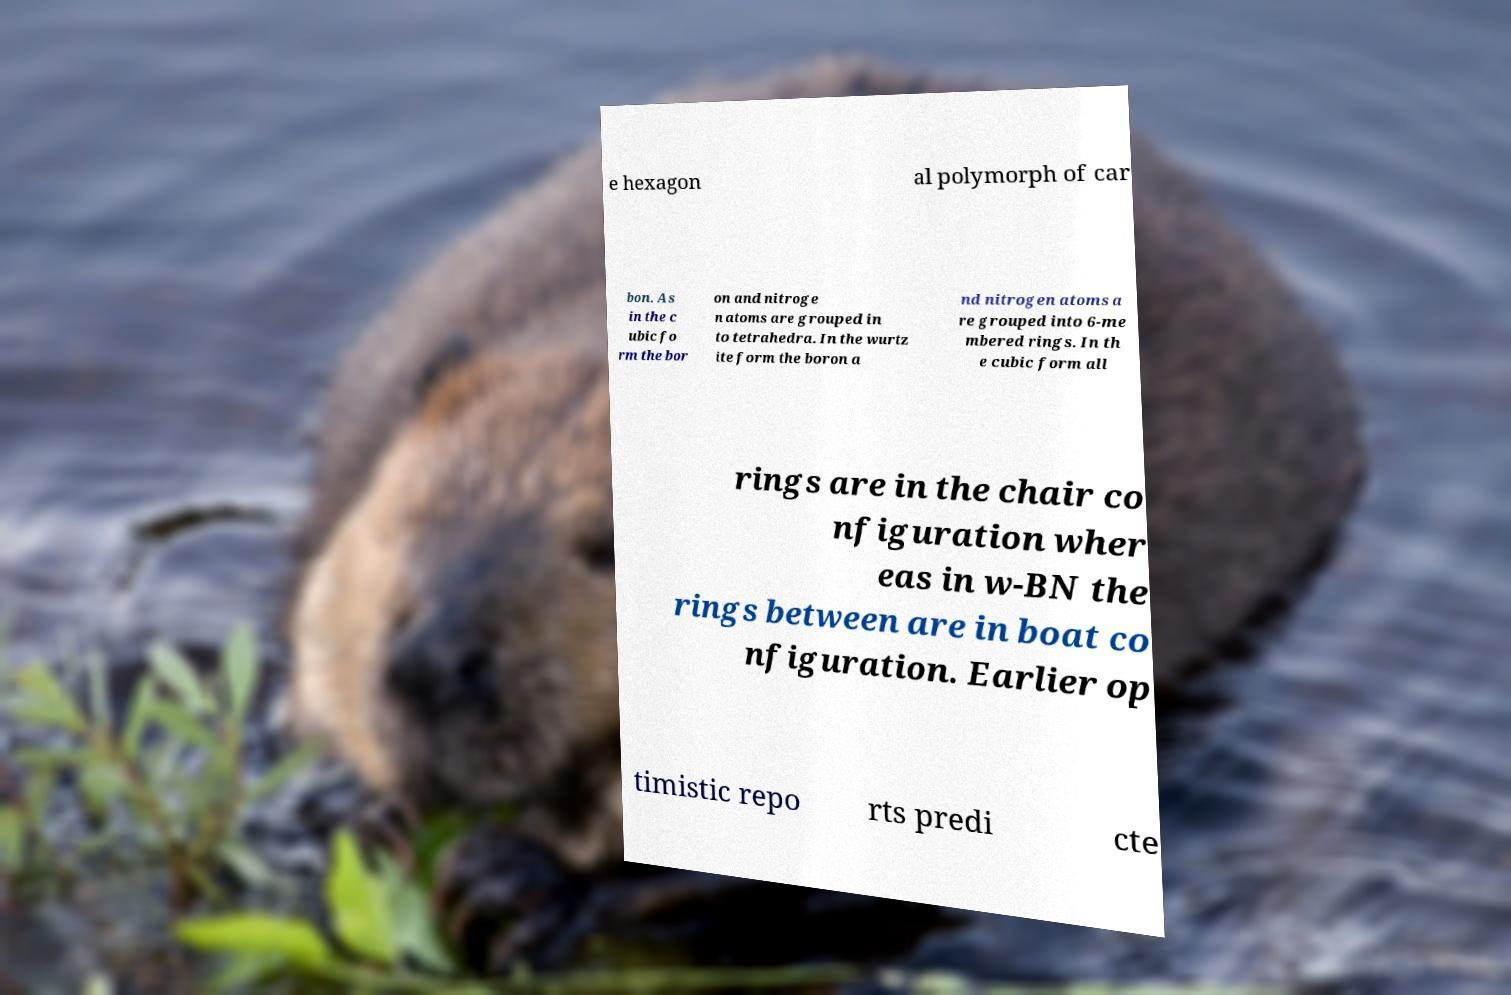For documentation purposes, I need the text within this image transcribed. Could you provide that? e hexagon al polymorph of car bon. As in the c ubic fo rm the bor on and nitroge n atoms are grouped in to tetrahedra. In the wurtz ite form the boron a nd nitrogen atoms a re grouped into 6-me mbered rings. In th e cubic form all rings are in the chair co nfiguration wher eas in w-BN the rings between are in boat co nfiguration. Earlier op timistic repo rts predi cte 